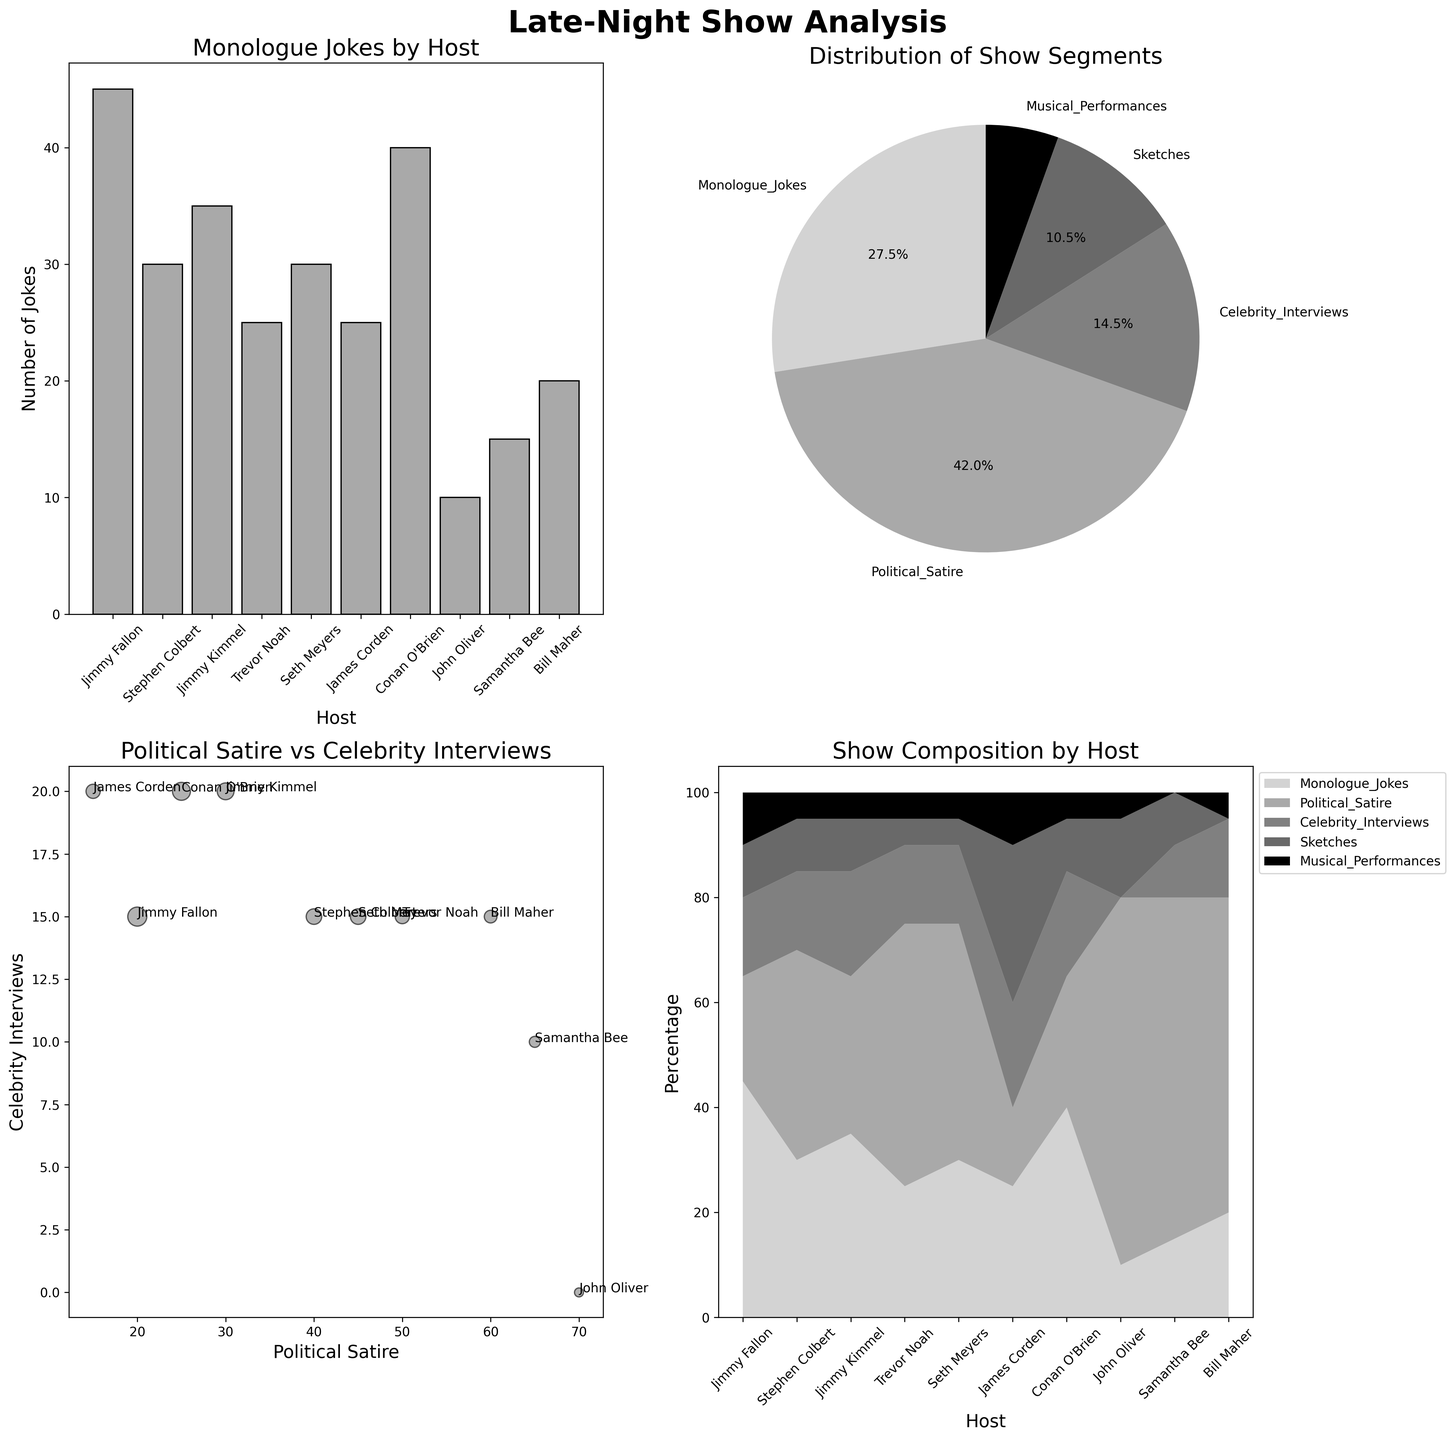What's the title of the overall figure? The overall title can be found at the top center of the figure. It reads "Late-Night Show Analysis".
Answer: Late-Night Show Analysis Which host has the highest number of monologue jokes? Examine the bar plot, which shows the number of monologue jokes for each host. Jimmy Fallon has the tallest bar in this plot.
Answer: Jimmy Fallon What is the total percentage of Political Satire and Musical Performances combined? In the pie chart subplot, locate the slices labeled 'Political Satire' and 'Musical Performances'. Then, add their percentages: Political Satire (36.7%) + Musical Performances (4.4%) = 41.1%.
Answer: 41.1% Is the number of monologue jokes for Seth Meyers greater than for Samantha Bee? Refer to the bar plot for 'Monologue Jokes by Host' and compare the heights of the bars for Seth Meyers and Samantha Bee. Seth Meyers has more monologue jokes than Samantha Bee.
Answer: Yes What is the title of the scatter plot in the lower left? Look at the title directly above the scatter plot in the lower left quadrant of the figure. It reads "Political Satire vs Celebrity Interviews".
Answer: Political Satire vs Celebrity Interviews Which show format is least frequent based on the pie chart? Check the pie chart "Distribution of Show Segments" and identify the smallest slice. Musical Performances have the smallest slice.
Answer: Musical Performances How many hosts have more than 40 instances of Political Satire? Refer to the stacked area chart or the scatter plot to identify the hosts. Stephen Colbert, Trevor Noah, Seth Meyers, John Oliver, and Samantha Bee all have more than 40 instances. There are 5 hosts in total.
Answer: 5 hosts Who has more sketches, Jimmy Fallon or James Corden? Look at the bar plot and read the heights for sketches for both hosts. James Corden has more sketches than Jimmy Fallon.
Answer: James Corden What's the sum of Celebrity Interviews for Jimmy Kimmel and Conan O'Brien? In the data or bar plot, Jimmy Kimmel has 20 Celebrity Interviews and Conan O'Brien has 20. The sum is 20 + 20 = 40.
Answer: 40 Which host has the highest number of political satire jokes and how many does he have? In the bar plot for Political Satire or the scatter plot, John Oliver has the highest number of political satire jokes with 70 instances.
Answer: John Oliver, 70 